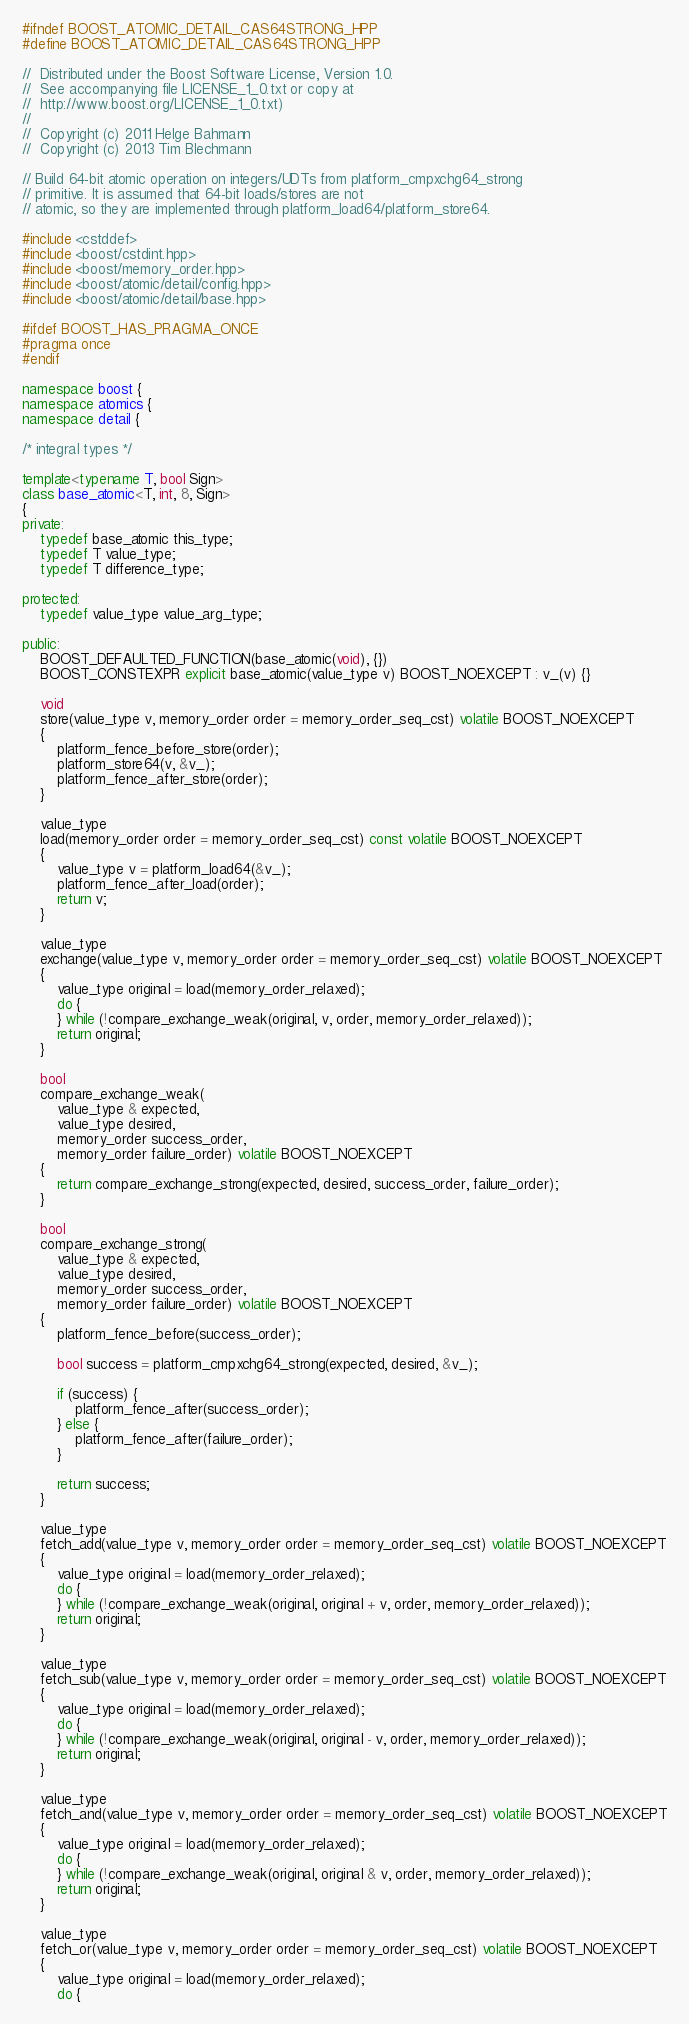<code> <loc_0><loc_0><loc_500><loc_500><_C++_>#ifndef BOOST_ATOMIC_DETAIL_CAS64STRONG_HPP
#define BOOST_ATOMIC_DETAIL_CAS64STRONG_HPP

//  Distributed under the Boost Software License, Version 1.0.
//  See accompanying file LICENSE_1_0.txt or copy at
//  http://www.boost.org/LICENSE_1_0.txt)
//
//  Copyright (c) 2011 Helge Bahmann
//  Copyright (c) 2013 Tim Blechmann

// Build 64-bit atomic operation on integers/UDTs from platform_cmpxchg64_strong
// primitive. It is assumed that 64-bit loads/stores are not
// atomic, so they are implemented through platform_load64/platform_store64.

#include <cstddef>
#include <boost/cstdint.hpp>
#include <boost/memory_order.hpp>
#include <boost/atomic/detail/config.hpp>
#include <boost/atomic/detail/base.hpp>

#ifdef BOOST_HAS_PRAGMA_ONCE
#pragma once
#endif

namespace boost {
namespace atomics {
namespace detail {

/* integral types */

template<typename T, bool Sign>
class base_atomic<T, int, 8, Sign>
{
private:
    typedef base_atomic this_type;
    typedef T value_type;
    typedef T difference_type;

protected:
    typedef value_type value_arg_type;

public:
    BOOST_DEFAULTED_FUNCTION(base_atomic(void), {})
    BOOST_CONSTEXPR explicit base_atomic(value_type v) BOOST_NOEXCEPT : v_(v) {}

    void
    store(value_type v, memory_order order = memory_order_seq_cst) volatile BOOST_NOEXCEPT
    {
        platform_fence_before_store(order);
        platform_store64(v, &v_);
        platform_fence_after_store(order);
    }

    value_type
    load(memory_order order = memory_order_seq_cst) const volatile BOOST_NOEXCEPT
    {
        value_type v = platform_load64(&v_);
        platform_fence_after_load(order);
        return v;
    }

    value_type
    exchange(value_type v, memory_order order = memory_order_seq_cst) volatile BOOST_NOEXCEPT
    {
        value_type original = load(memory_order_relaxed);
        do {
        } while (!compare_exchange_weak(original, v, order, memory_order_relaxed));
        return original;
    }

    bool
    compare_exchange_weak(
        value_type & expected,
        value_type desired,
        memory_order success_order,
        memory_order failure_order) volatile BOOST_NOEXCEPT
    {
        return compare_exchange_strong(expected, desired, success_order, failure_order);
    }

    bool
    compare_exchange_strong(
        value_type & expected,
        value_type desired,
        memory_order success_order,
        memory_order failure_order) volatile BOOST_NOEXCEPT
    {
        platform_fence_before(success_order);

        bool success = platform_cmpxchg64_strong(expected, desired, &v_);

        if (success) {
            platform_fence_after(success_order);
        } else {
            platform_fence_after(failure_order);
        }

        return success;
    }

    value_type
    fetch_add(value_type v, memory_order order = memory_order_seq_cst) volatile BOOST_NOEXCEPT
    {
        value_type original = load(memory_order_relaxed);
        do {
        } while (!compare_exchange_weak(original, original + v, order, memory_order_relaxed));
        return original;
    }

    value_type
    fetch_sub(value_type v, memory_order order = memory_order_seq_cst) volatile BOOST_NOEXCEPT
    {
        value_type original = load(memory_order_relaxed);
        do {
        } while (!compare_exchange_weak(original, original - v, order, memory_order_relaxed));
        return original;
    }

    value_type
    fetch_and(value_type v, memory_order order = memory_order_seq_cst) volatile BOOST_NOEXCEPT
    {
        value_type original = load(memory_order_relaxed);
        do {
        } while (!compare_exchange_weak(original, original & v, order, memory_order_relaxed));
        return original;
    }

    value_type
    fetch_or(value_type v, memory_order order = memory_order_seq_cst) volatile BOOST_NOEXCEPT
    {
        value_type original = load(memory_order_relaxed);
        do {</code> 